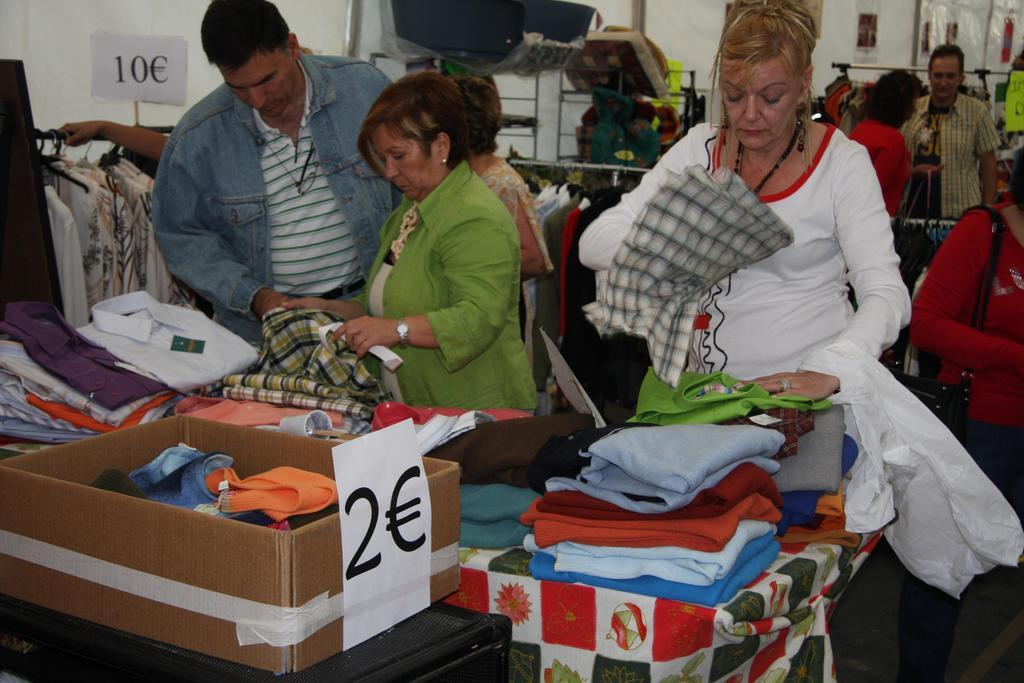What objects are on the table in the image? There are cloths on a table in the image. What are the people holding in their hands? The people are holding cloths in the image. Can you describe the positions of the people in the image? Some people are standing in the image. What can be seen in the background of the image? In the background, there are cloths hanged on poles. What channel is the mother watching on TV in the image? There is no mention of a TV or a mother in the image; it features cloths on a table, people holding cloths, and cloths hanged on poles in the background. What type of insect is crawling on the cloths in the image? There is no insect present in the image. 